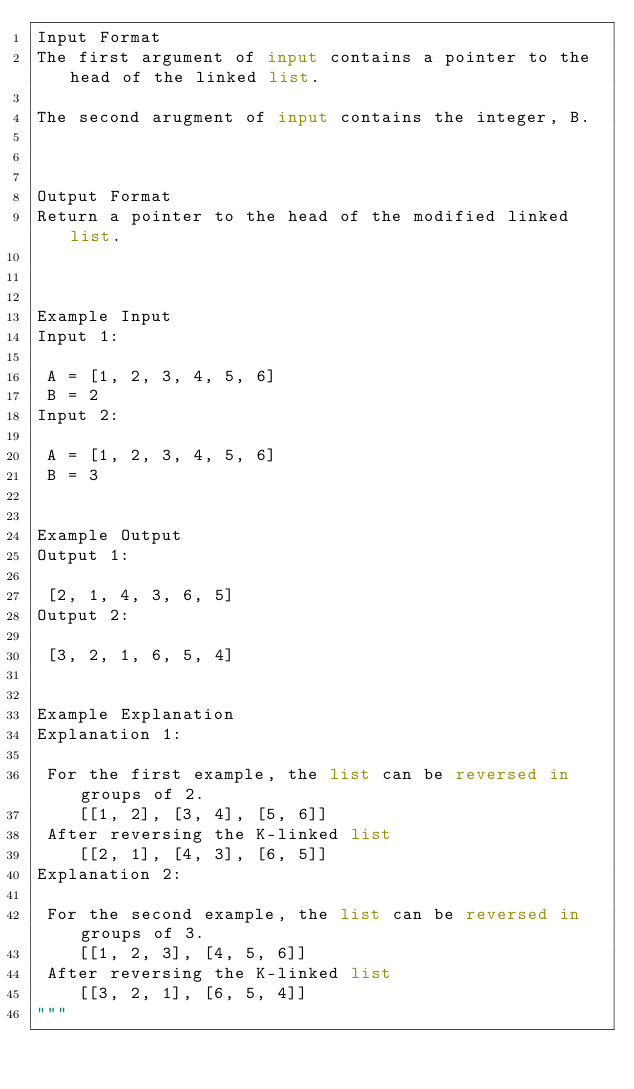<code> <loc_0><loc_0><loc_500><loc_500><_Python_>Input Format
The first argument of input contains a pointer to the head of the linked list.

The second arugment of input contains the integer, B.



Output Format
Return a pointer to the head of the modified linked list.



Example Input
Input 1:

 A = [1, 2, 3, 4, 5, 6]
 B = 2
Input 2:

 A = [1, 2, 3, 4, 5, 6]
 B = 3


Example Output
Output 1:

 [2, 1, 4, 3, 6, 5]
Output 2:

 [3, 2, 1, 6, 5, 4]


Example Explanation
Explanation 1:

 For the first example, the list can be reversed in groups of 2.
    [[1, 2], [3, 4], [5, 6]]
 After reversing the K-linked list
    [[2, 1], [4, 3], [6, 5]]
Explanation 2:

 For the second example, the list can be reversed in groups of 3.
    [[1, 2, 3], [4, 5, 6]]
 After reversing the K-linked list
    [[3, 2, 1], [6, 5, 4]]
"""</code> 